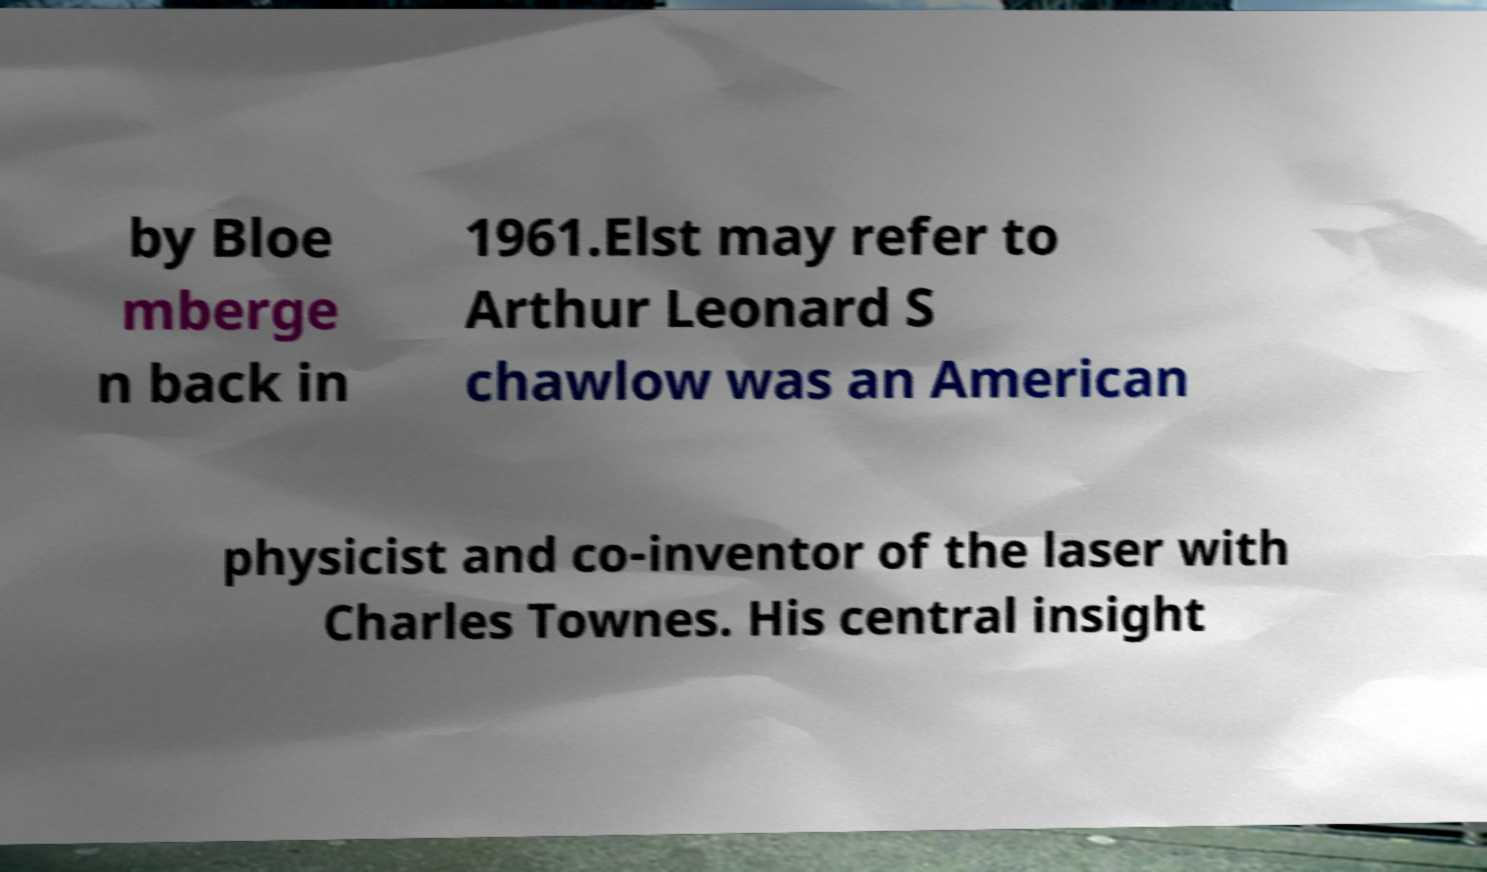For documentation purposes, I need the text within this image transcribed. Could you provide that? by Bloe mberge n back in 1961.Elst may refer to Arthur Leonard S chawlow was an American physicist and co-inventor of the laser with Charles Townes. His central insight 